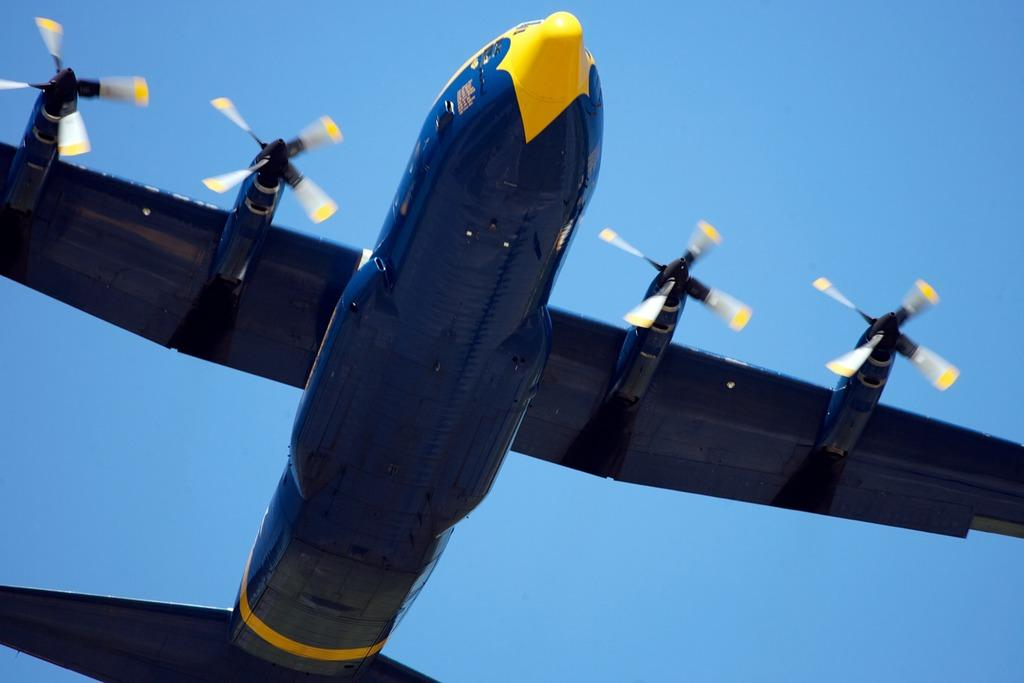What is flying in the sky in the image? There is an aircraft in the sky in the image. What color is the sky in the image? The sky is blue in color. How many birds are chained together in the image? There are no birds or chains present in the image. 